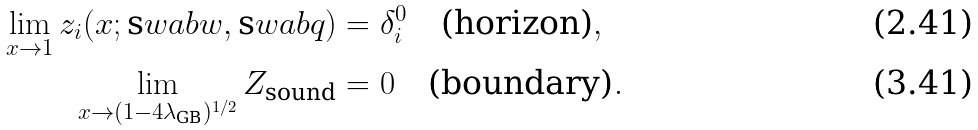Convert formula to latex. <formula><loc_0><loc_0><loc_500><loc_500>\lim _ { x \to 1 } z _ { i } ( x ; \text  swab{w} , \text  swab{q} ) & = \delta ^ { 0 } _ { i } \quad \text {(horizon)} , \\ \lim _ { x \to ( 1 - 4 \lambda _ { \text {GB} } ) ^ { 1 / 2 } } Z _ { \text {sound} } & = 0 \quad \text {(boundary)} .</formula> 